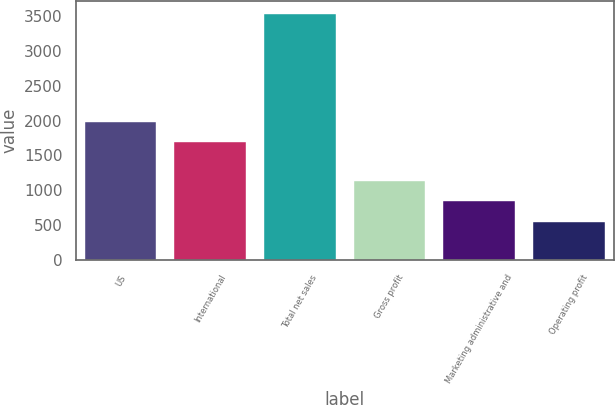Convert chart to OTSL. <chart><loc_0><loc_0><loc_500><loc_500><bar_chart><fcel>US<fcel>International<fcel>Total net sales<fcel>Gross profit<fcel>Marketing administrative and<fcel>Operating profit<nl><fcel>1986.2<fcel>1687.1<fcel>3531.9<fcel>1139.1<fcel>840<fcel>540.9<nl></chart> 